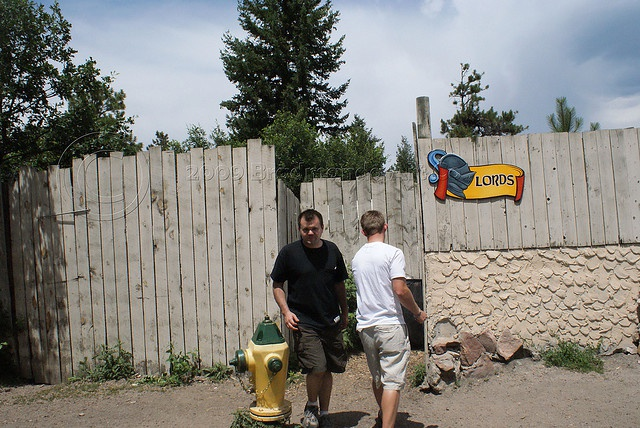Describe the objects in this image and their specific colors. I can see people in black, gray, maroon, and darkgray tones, people in black, lightgray, darkgray, and gray tones, and fire hydrant in black, olive, and khaki tones in this image. 